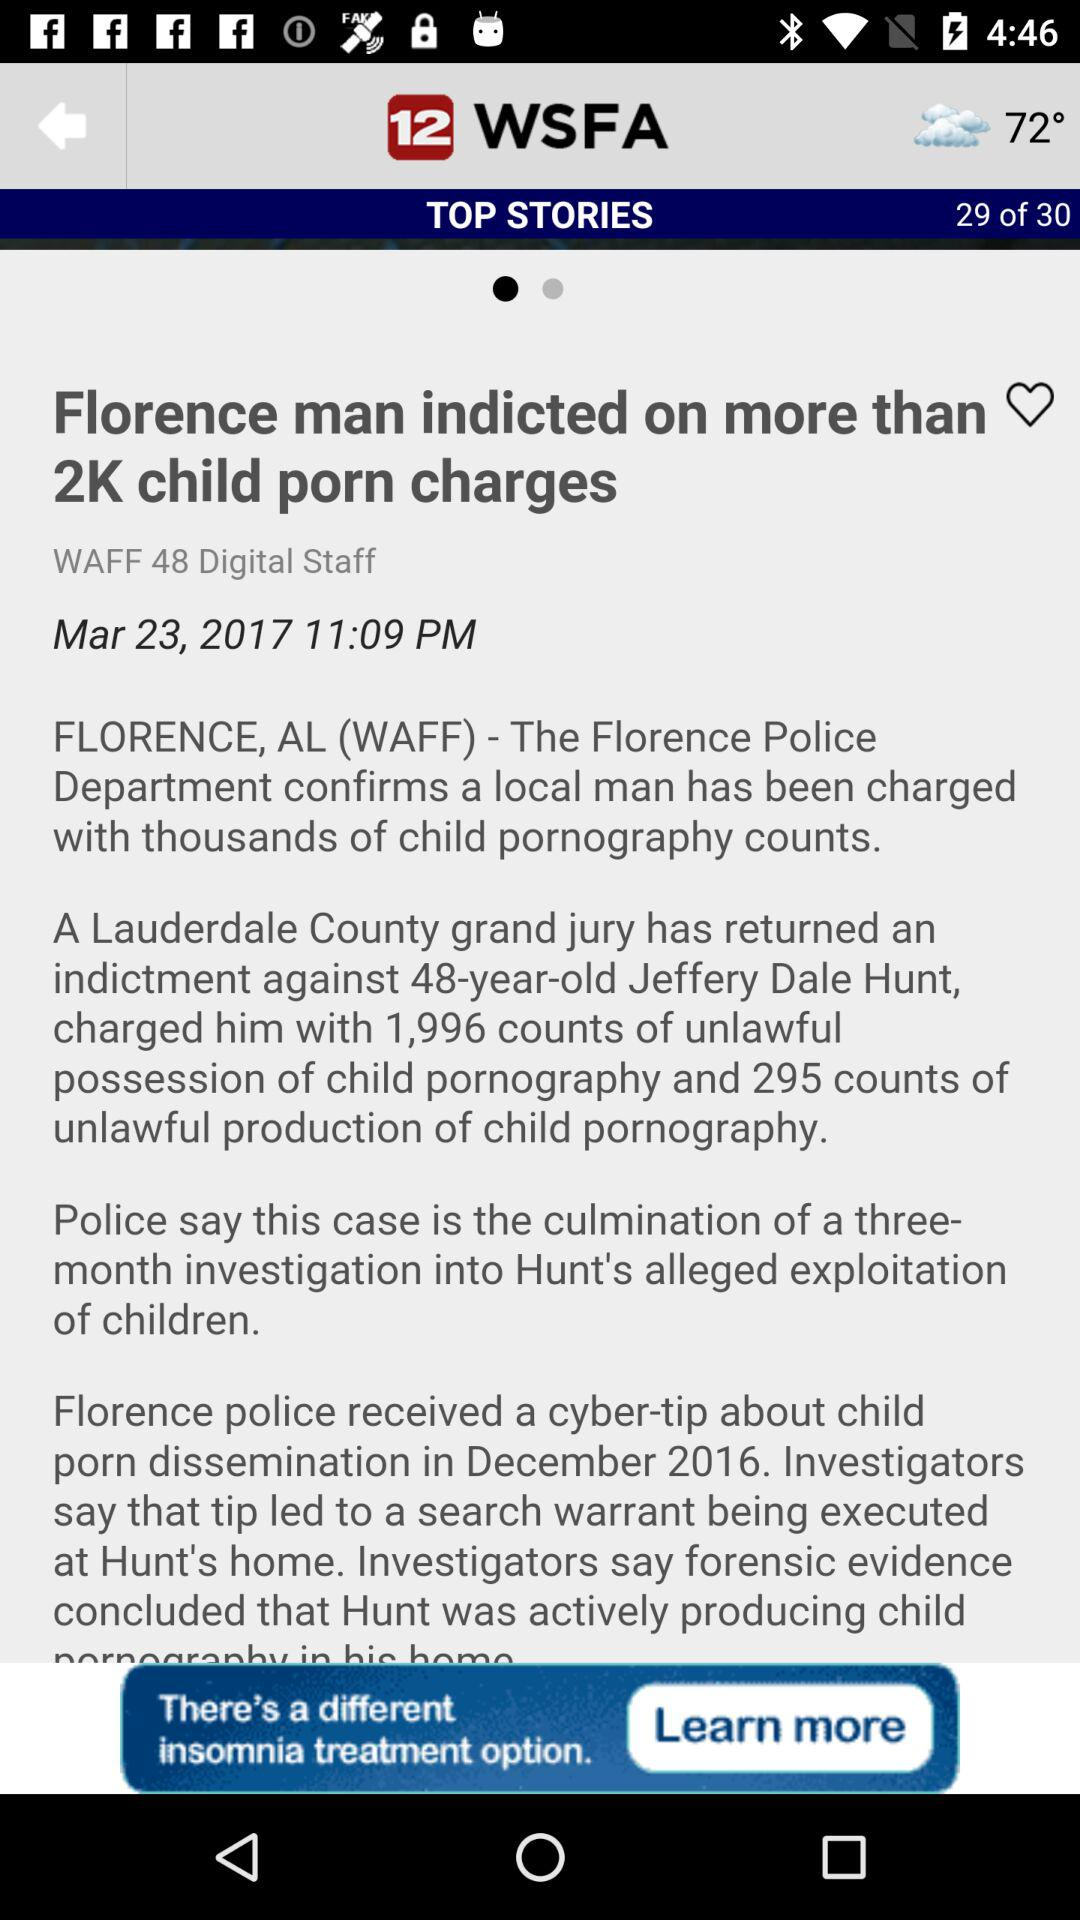On what page is the person currently? The person is on page 29. 